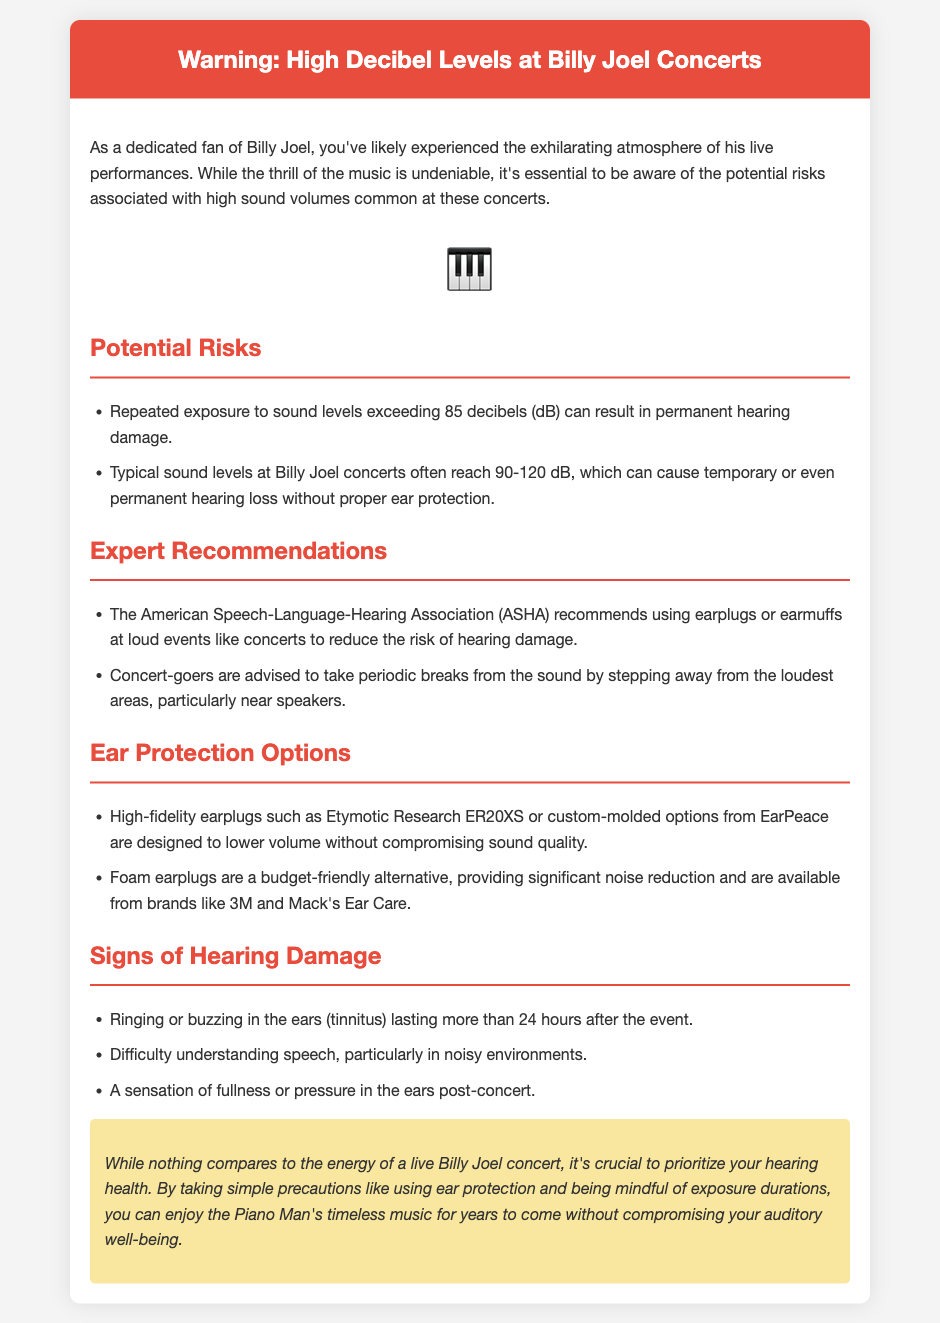What is the title of the document? The title of the document is clearly stated at the top of the rendered document.
Answer: Warning: High Decibel Levels at Billy Joel Concerts What sound levels can typically be expected at Billy Joel concerts? The document specifies a range of sound levels that are typical for these concerts.
Answer: 90-120 dB What does ASHA recommend using at loud events? The document includes expert recommendations from ASHA regarding hearing protection.
Answer: Earplugs What are signs of hearing damage after a concert? The document lists specific symptoms that indicate possible hearing damage.
Answer: Ringing or buzzing in the ears What type of earplugs are designed to lower volume without compromising sound quality? The document mentions specific types of earplugs that provide high fidelity.
Answer: High-fidelity earplugs What should concert-goers do to reduce the risk of hearing damage? The document provides recommendations on actions to take at concerts for hearing safety.
Answer: Take periodic breaks How long does ringing in the ears indicate potential hearing damage? The document specifies a duration for which ringing in the ears may suggest hearing damage.
Answer: More than 24 hours What is a budget-friendly alternative for ear protection mentioned in the document? The document states specific types of earplugs that are more affordable.
Answer: Foam earplugs 